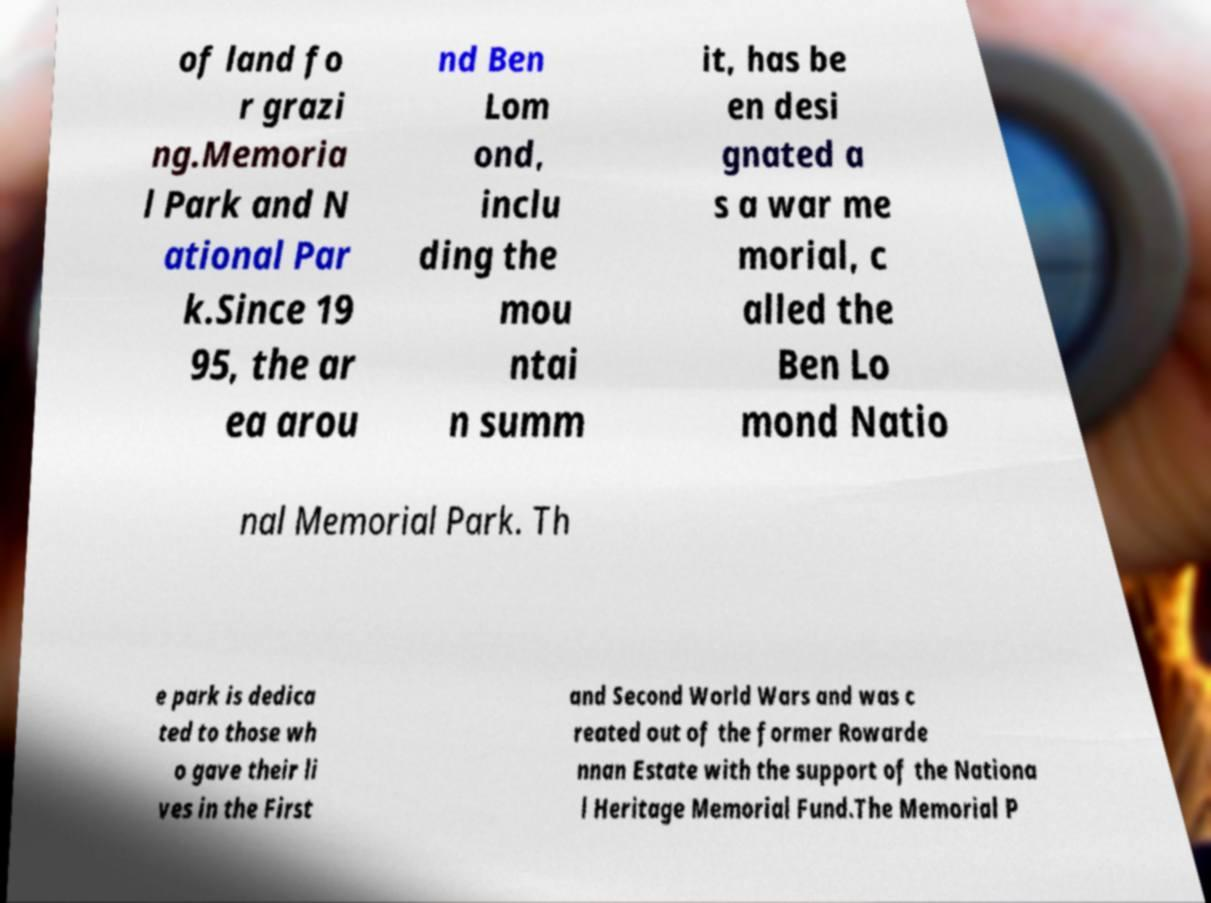I need the written content from this picture converted into text. Can you do that? of land fo r grazi ng.Memoria l Park and N ational Par k.Since 19 95, the ar ea arou nd Ben Lom ond, inclu ding the mou ntai n summ it, has be en desi gnated a s a war me morial, c alled the Ben Lo mond Natio nal Memorial Park. Th e park is dedica ted to those wh o gave their li ves in the First and Second World Wars and was c reated out of the former Rowarde nnan Estate with the support of the Nationa l Heritage Memorial Fund.The Memorial P 